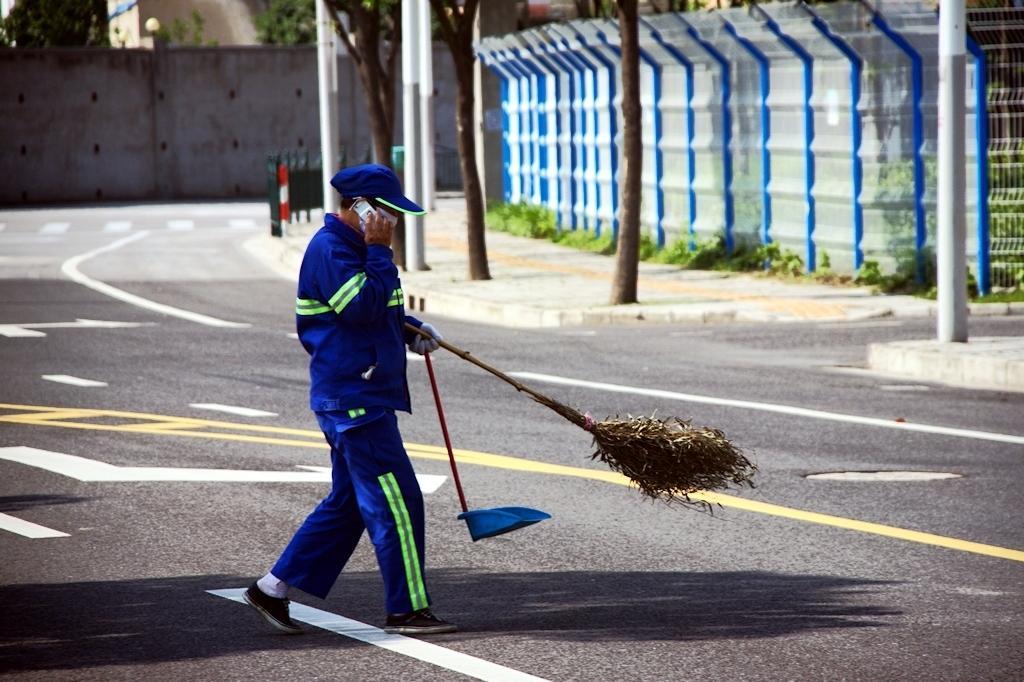Could you give a brief overview of what you see in this image? Here we can see a man holding a broomstick with his hand and he is talking on the mobile. This is a road. In the background we can see a wall, fence, plants, and trees. 